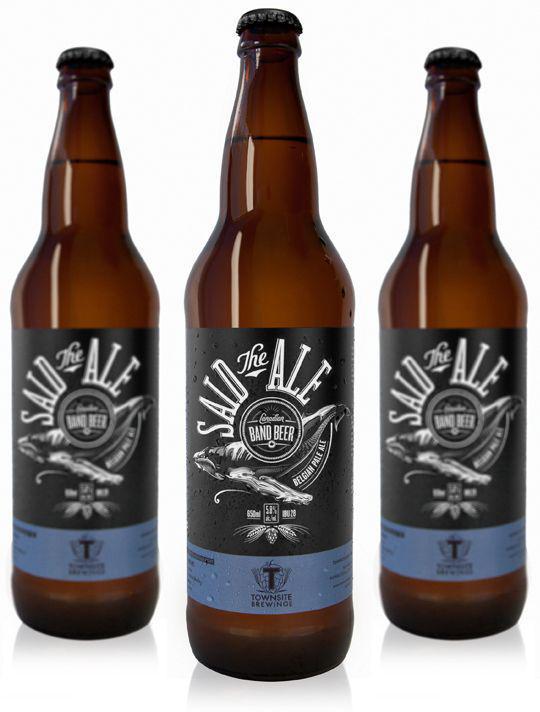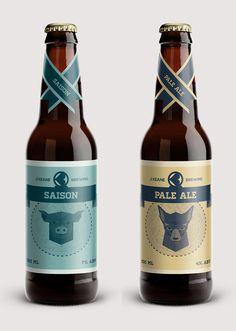The first image is the image on the left, the second image is the image on the right. Assess this claim about the two images: "A total of five beer bottles are depicted.". Correct or not? Answer yes or no. Yes. 